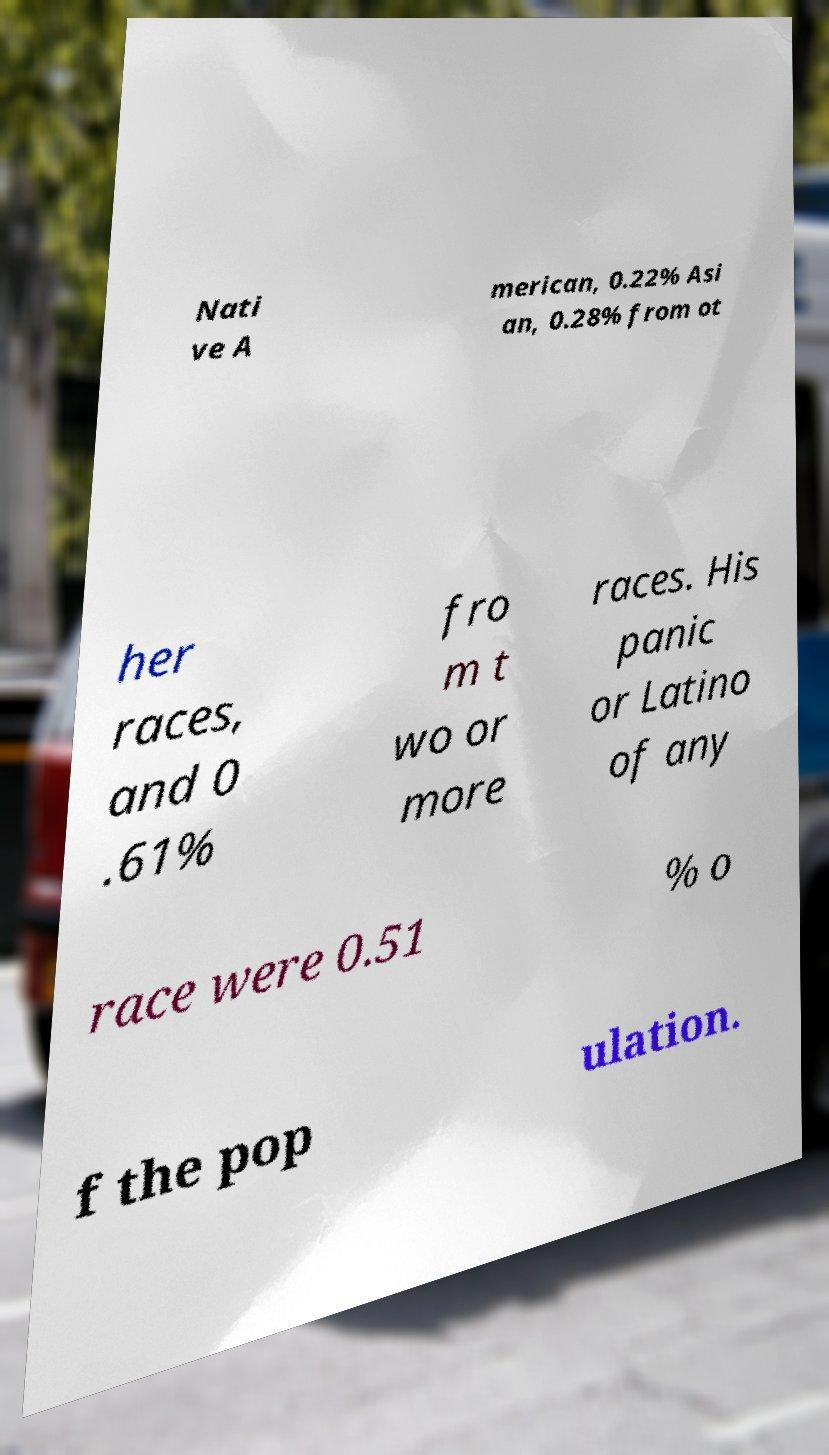There's text embedded in this image that I need extracted. Can you transcribe it verbatim? Nati ve A merican, 0.22% Asi an, 0.28% from ot her races, and 0 .61% fro m t wo or more races. His panic or Latino of any race were 0.51 % o f the pop ulation. 